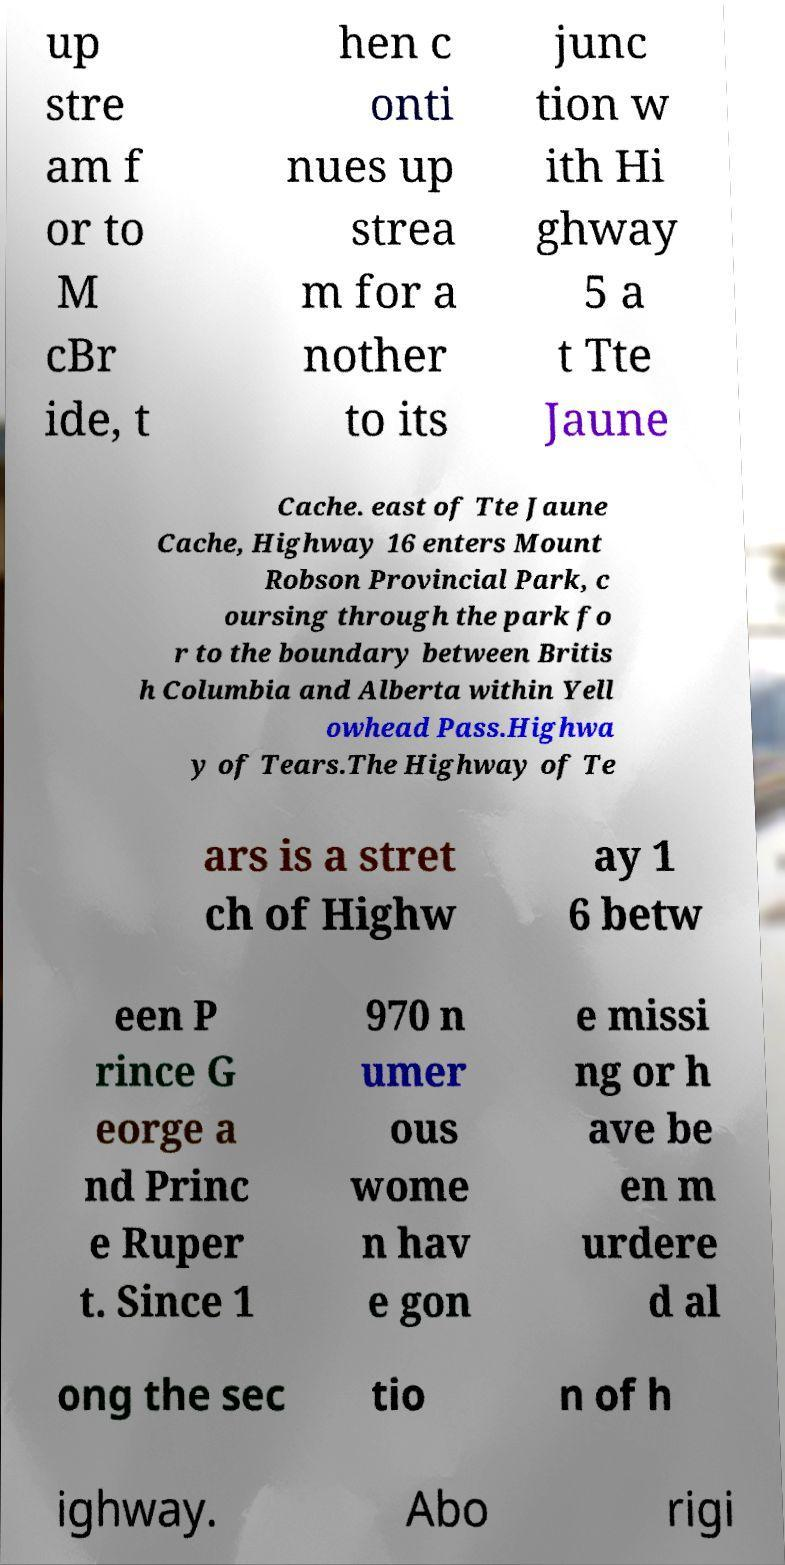Can you read and provide the text displayed in the image?This photo seems to have some interesting text. Can you extract and type it out for me? up stre am f or to M cBr ide, t hen c onti nues up strea m for a nother to its junc tion w ith Hi ghway 5 a t Tte Jaune Cache. east of Tte Jaune Cache, Highway 16 enters Mount Robson Provincial Park, c oursing through the park fo r to the boundary between Britis h Columbia and Alberta within Yell owhead Pass.Highwa y of Tears.The Highway of Te ars is a stret ch of Highw ay 1 6 betw een P rince G eorge a nd Princ e Ruper t. Since 1 970 n umer ous wome n hav e gon e missi ng or h ave be en m urdere d al ong the sec tio n of h ighway. Abo rigi 